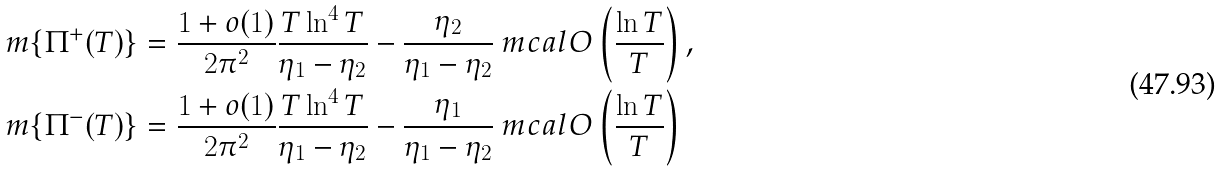<formula> <loc_0><loc_0><loc_500><loc_500>m \{ \Pi ^ { + } ( T ) \} & = \frac { 1 + o ( 1 ) } { 2 \pi ^ { 2 } } \frac { T \ln ^ { 4 } T } { \eta _ { 1 } - \eta _ { 2 } } - \frac { \eta _ { 2 } } { \eta _ { 1 } - \eta _ { 2 } } \ m c a l { O } \left ( \frac { \ln T } { T } \right ) , \\ m \{ \Pi ^ { - } ( T ) \} & = \frac { 1 + o ( 1 ) } { 2 \pi ^ { 2 } } \frac { T \ln ^ { 4 } T } { \eta _ { 1 } - \eta _ { 2 } } - \frac { \eta _ { 1 } } { \eta _ { 1 } - \eta _ { 2 } } \ m c a l { O } \left ( \frac { \ln T } { T } \right )</formula> 